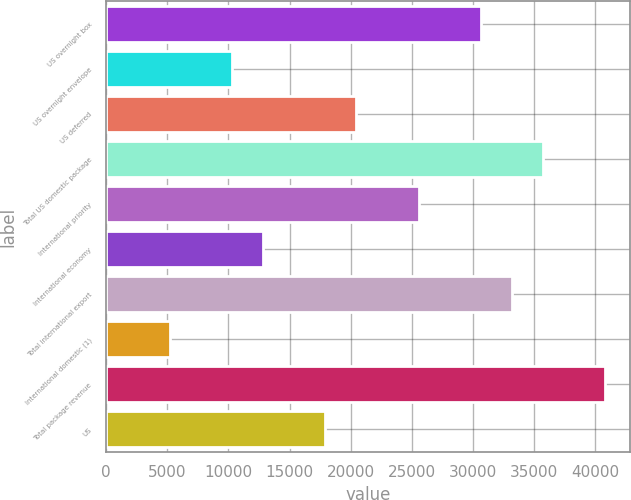<chart> <loc_0><loc_0><loc_500><loc_500><bar_chart><fcel>US overnight box<fcel>US overnight envelope<fcel>US deferred<fcel>Total US domestic package<fcel>International priority<fcel>International economy<fcel>Total international export<fcel>International domestic (1)<fcel>Total package revenue<fcel>US<nl><fcel>30638.4<fcel>10296.8<fcel>20467.6<fcel>35723.8<fcel>25553<fcel>12839.5<fcel>33181.1<fcel>5211.4<fcel>40809.2<fcel>17924.9<nl></chart> 